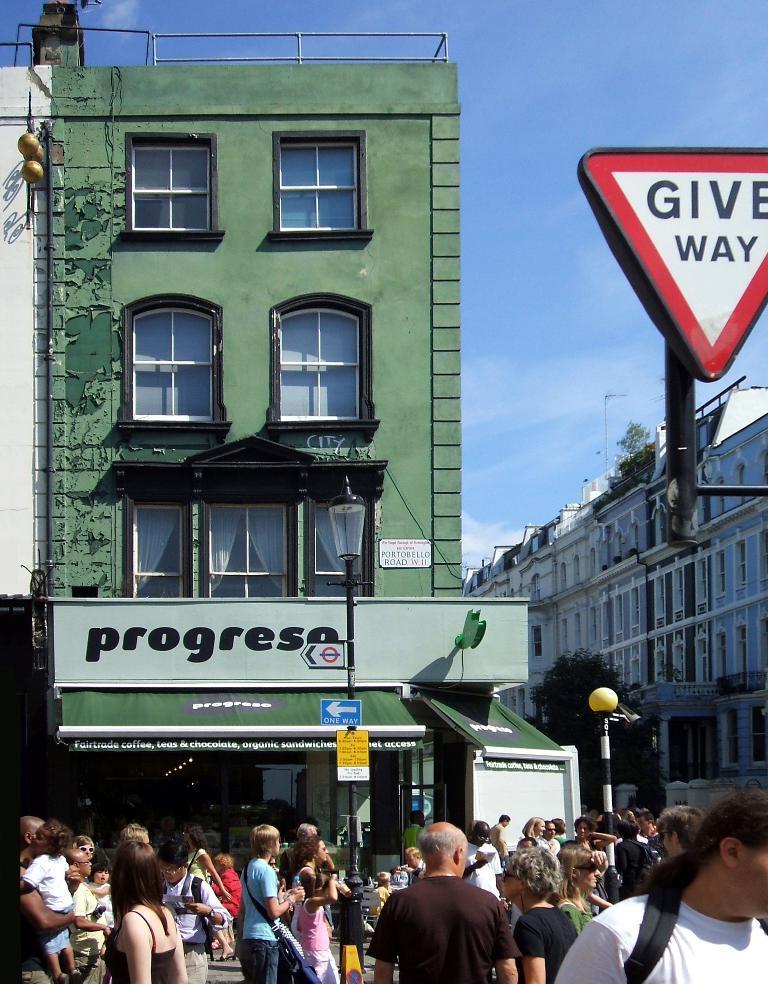How would you summarize this image in a sentence or two? In this image at the bottom, there are many people. In the middle there are buildings, sign boards, text, street lights, poles, windows, glasses, wall, sky and clouds. 